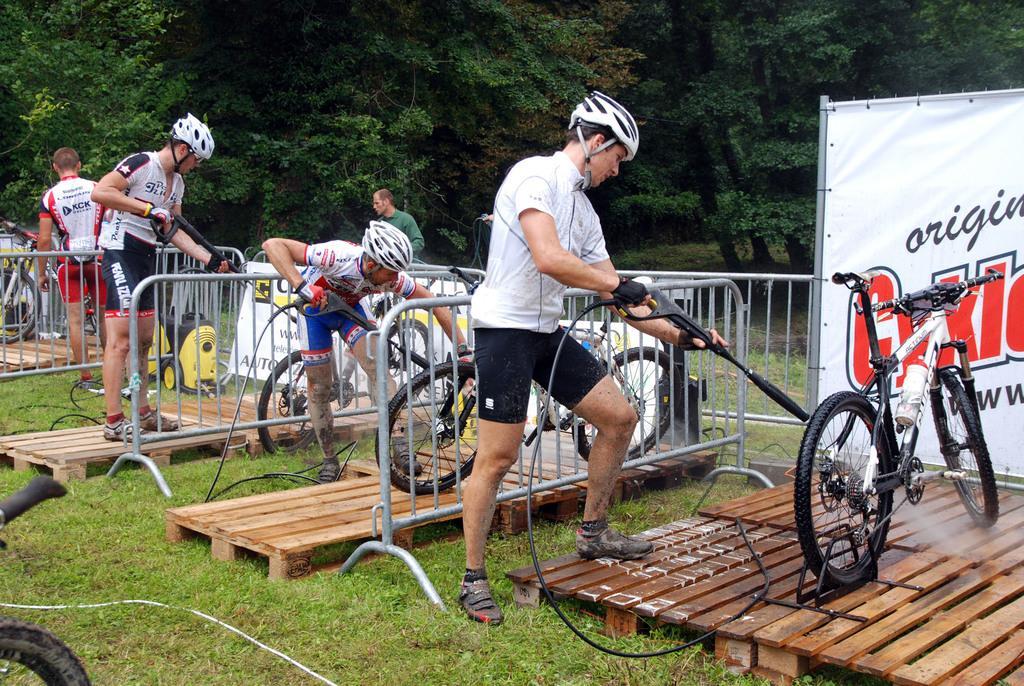In one or two sentences, can you explain what this image depicts? In this image, we can see people, bicycles, barricades, banners and wooden objects on the grass. Few people are holding some objects. In the background, there are few trees. 